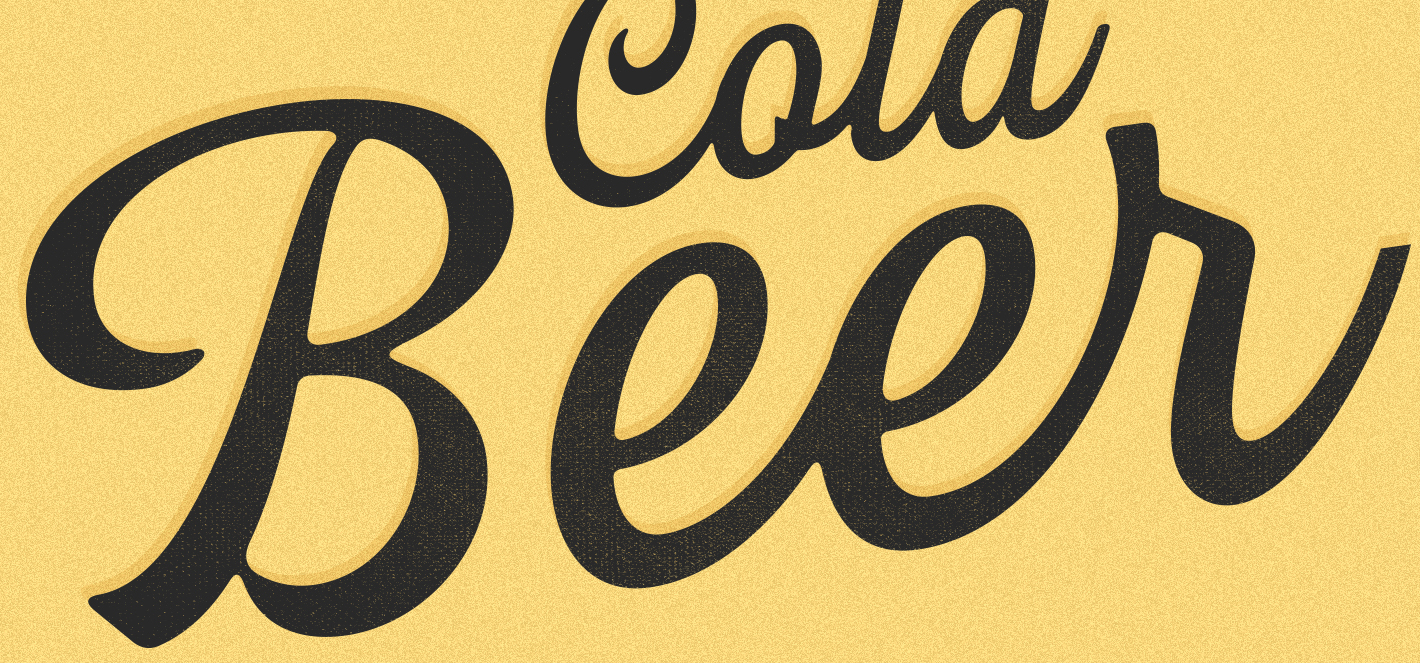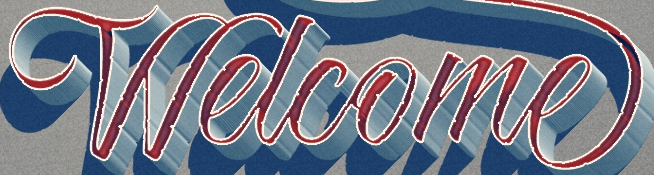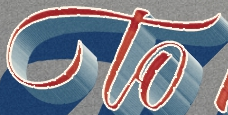What words can you see in these images in sequence, separated by a semicolon? Beer; Welcome; to 